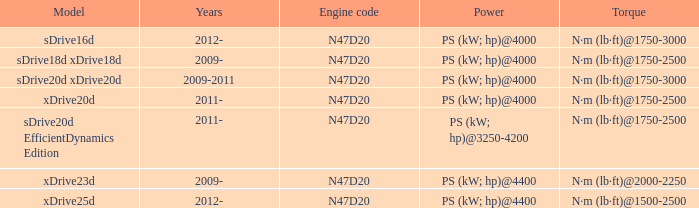For which years did the sdrive16d model possess a torque of n·m (lb·ft) in the 1750-3000 rpm range? 2012-. 